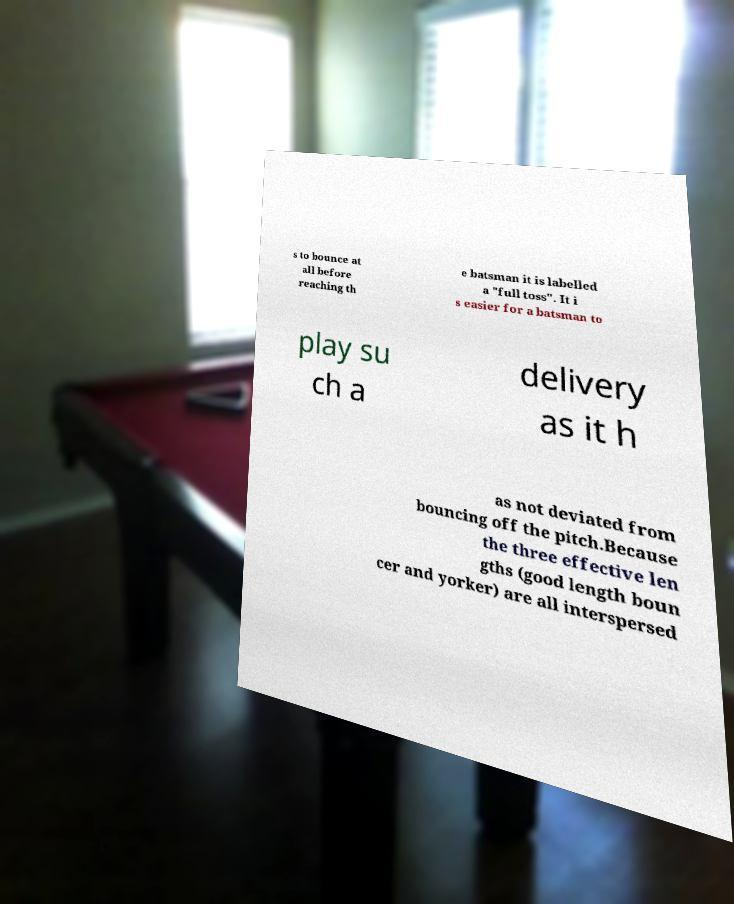Can you accurately transcribe the text from the provided image for me? s to bounce at all before reaching th e batsman it is labelled a "full toss". It i s easier for a batsman to play su ch a delivery as it h as not deviated from bouncing off the pitch.Because the three effective len gths (good length boun cer and yorker) are all interspersed 